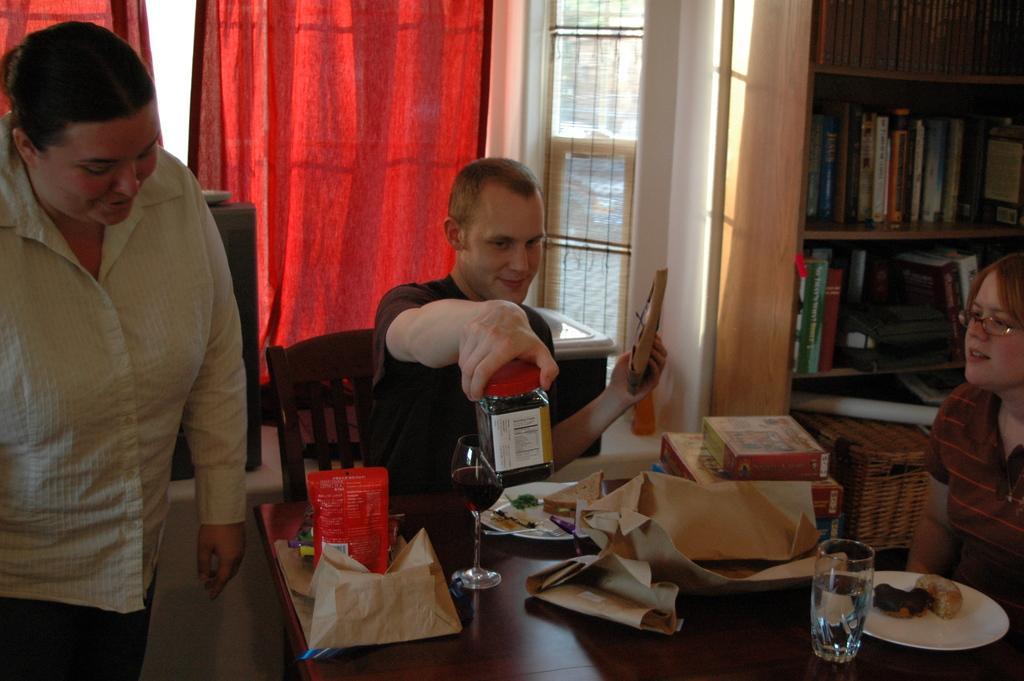Can you describe this image briefly? In this picture does a man holding an object with a woman here and there is another person sitting over here 